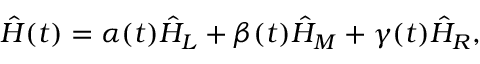Convert formula to latex. <formula><loc_0><loc_0><loc_500><loc_500>\hat { H } ( t ) = \alpha ( t ) \hat { H } _ { L } + \beta ( t ) \hat { H } _ { M } + \gamma ( t ) \hat { H } _ { R } ,</formula> 